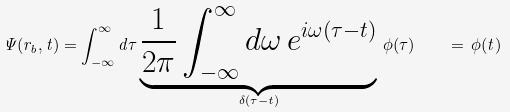<formula> <loc_0><loc_0><loc_500><loc_500>\Psi ( r _ { b } , t ) = \int _ { - \infty } ^ { \infty } d \tau \underbrace { \frac { 1 } { 2 \pi } \int _ { - \infty } ^ { \infty } d \omega \, e ^ { i \omega ( \tau - t ) } } _ { \delta ( \tau - t ) } \, \phi ( \tau ) \quad = \, \phi ( t )</formula> 